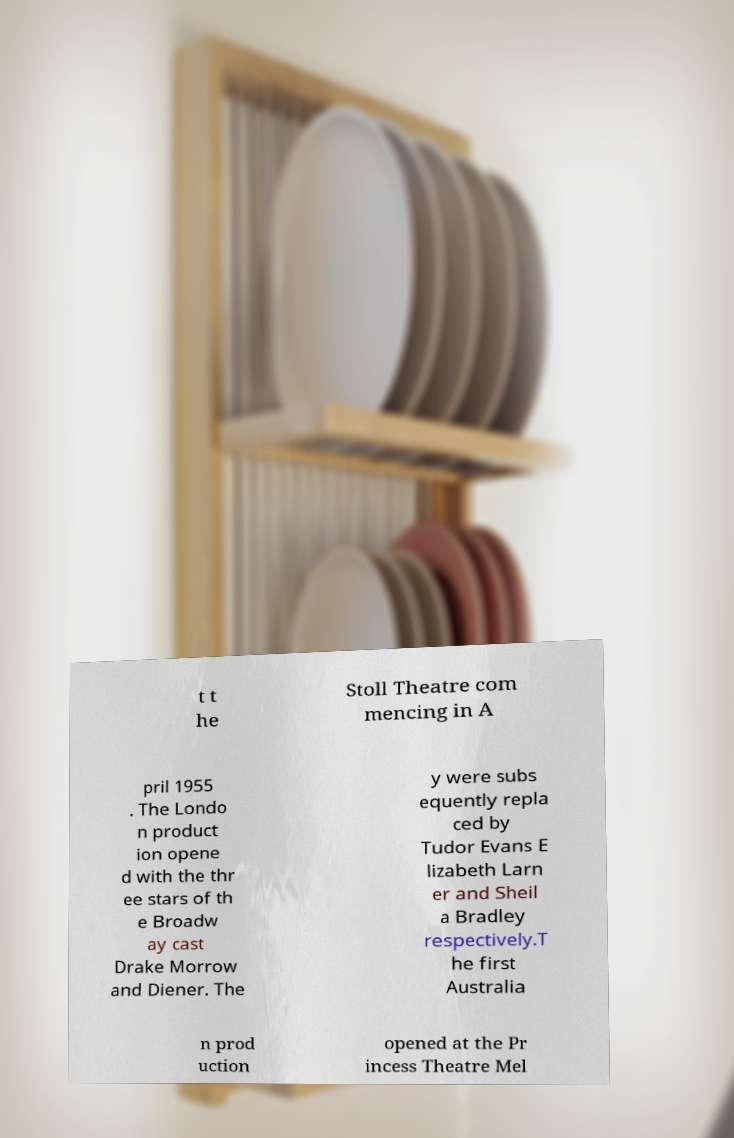Please identify and transcribe the text found in this image. t t he Stoll Theatre com mencing in A pril 1955 . The Londo n product ion opene d with the thr ee stars of th e Broadw ay cast Drake Morrow and Diener. The y were subs equently repla ced by Tudor Evans E lizabeth Larn er and Sheil a Bradley respectively.T he first Australia n prod uction opened at the Pr incess Theatre Mel 